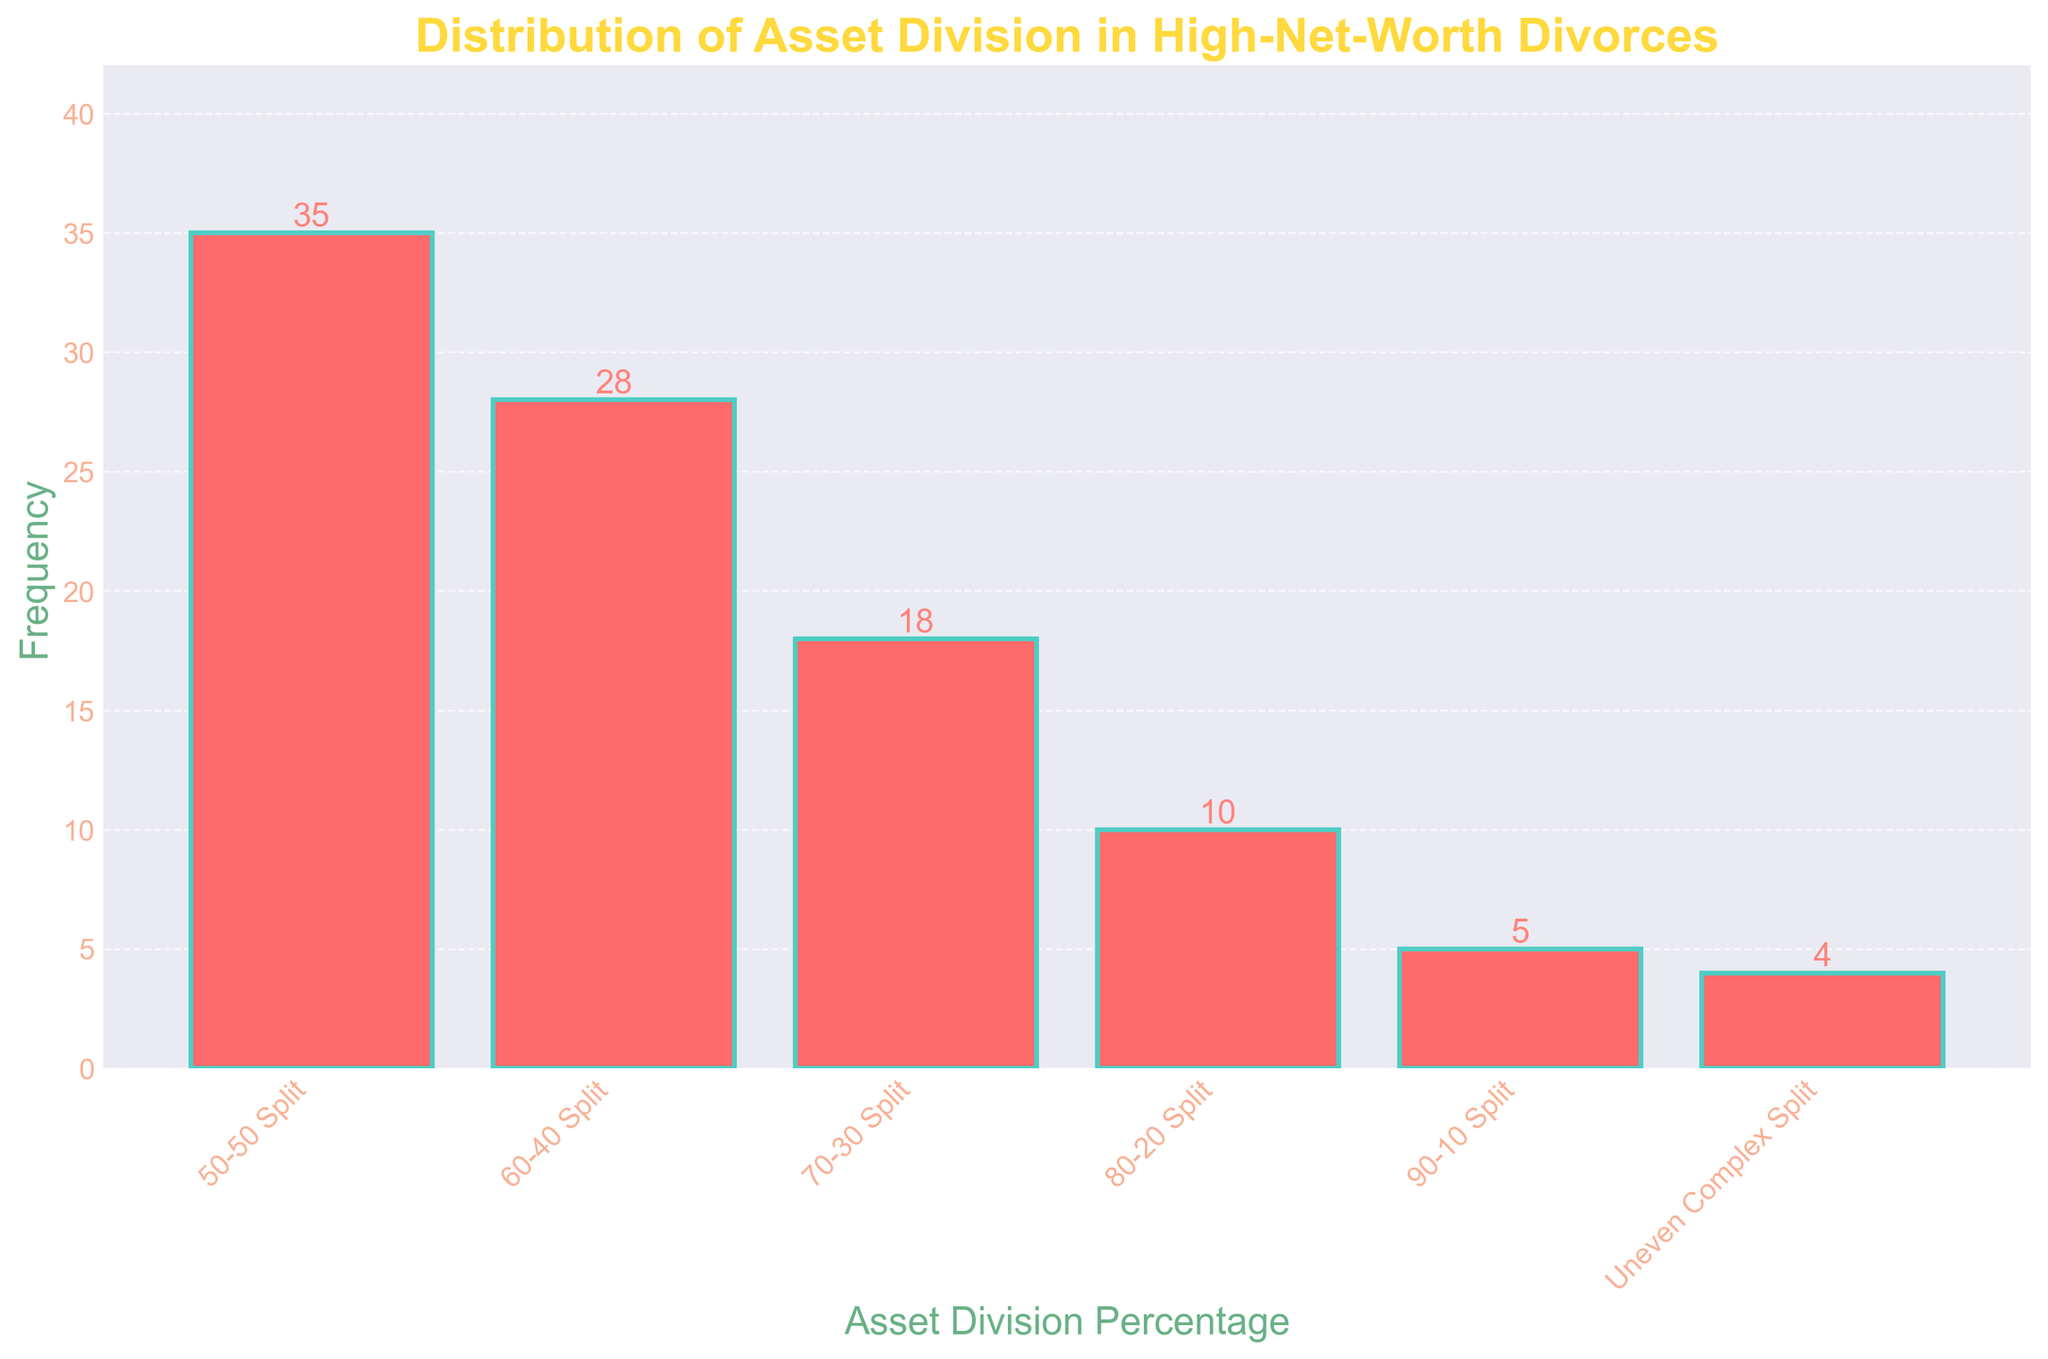What is the most common asset division percentage in high-net-worth divorces? The height of the bar representing the "50-50 Split" category is the tallest on the chart, indicating it has the highest frequency.
Answer: 50-50 Split Which asset division percentages have a higher frequency than the 70-30 split? The frequencies for "50-50 Split" (35) and "60-40 Split" (28) are both greater than the frequency for "70-30 Split" (18).
Answer: 50-50 Split, 60-40 Split What is the difference in frequency between the 80-20 split and the 90-10 split categories? The frequency for "80-20 Split" is 10 and for "90-10 Split" is 5. The difference between them is 10 - 5.
Answer: 5 How many asset division percentages have frequencies less than or equal to 10? The categories "80-20 Split" (10), "90-10 Split" (5), and "Uneven Complex Split" (4) all have frequencies less than or equal to 10.
Answer: 3 Which asset division percentage has the least frequency? The bar representing "Uneven Complex Split" has the lowest height, indicating it has the least frequency among all categories.
Answer: Uneven Complex Split What is the total frequency of all asset division percentages combined? The sum of frequencies across all categories is 35 + 28 + 18 + 10 + 5 + 4.
Answer: 100 Approximately what percentage of the total disposition frequency does the 50-50 split represent? Frequency of the "50-50 Split" is 35. The total frequency is 100. The percentage is calculated as (35 / 100) x 100%.
Answer: 35% Compare the 60-40 split and the uneven complex split in terms of frequency. How many times more frequent is the 60-40 split? The frequency for "60-40 Split" is 28 and for "Uneven Complex Split" is 4. The ratio is 28 / 4.
Answer: 7 times What is the combined frequency of the 50-50 split and 60-40 split? Adding frequencies for "50-50 Split" (35) and "60-40 Split" (28) gives the combined frequency as 35 + 28.
Answer: 63 Which asset division percentages fall within the range of frequency 5 to 20 inclusive? The categories "70-30 Split" (18), "80-20 Split" (10), and "90-10 Split" (5) have frequencies within the range of 5 to 20 inclusive.
Answer: 70-30 Split, 80-20 Split, 90-10 Split 